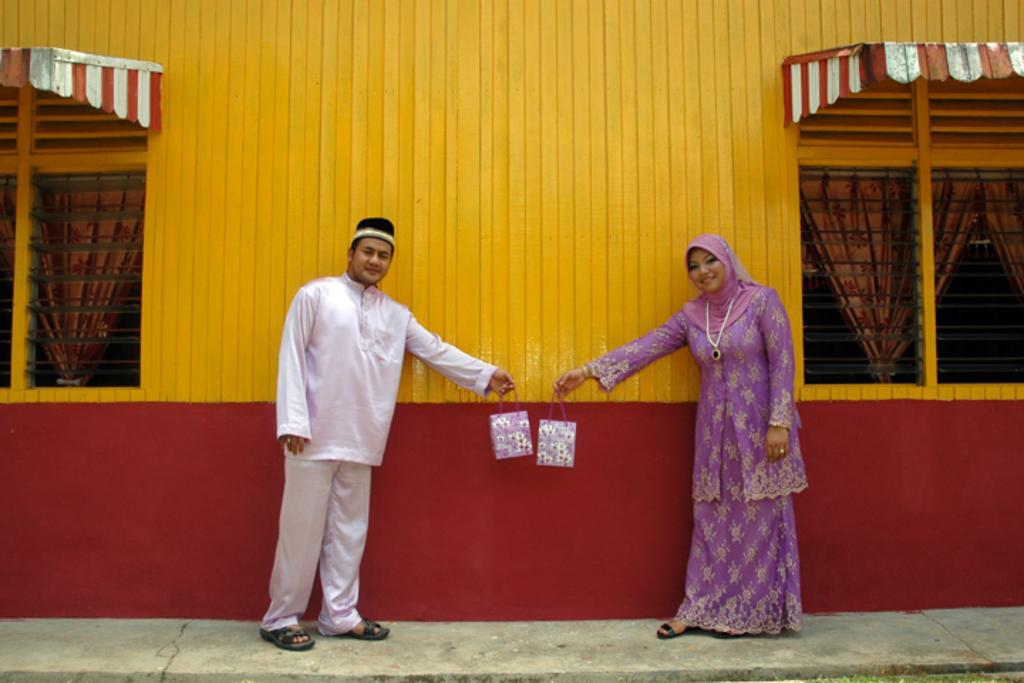How many people are in the image? There are two people in the image. What are the two people doing in the image? The two people are standing. What are the two people holding in the image? The two people are holding bags. What can be seen in the background of the image? There is a wall, windows, and curtains associated with the windows in the background of the image. What type of industry can be seen in the image? There is no industry present in the image. How many toes can be seen in the image? There are no toes visible in the image. 